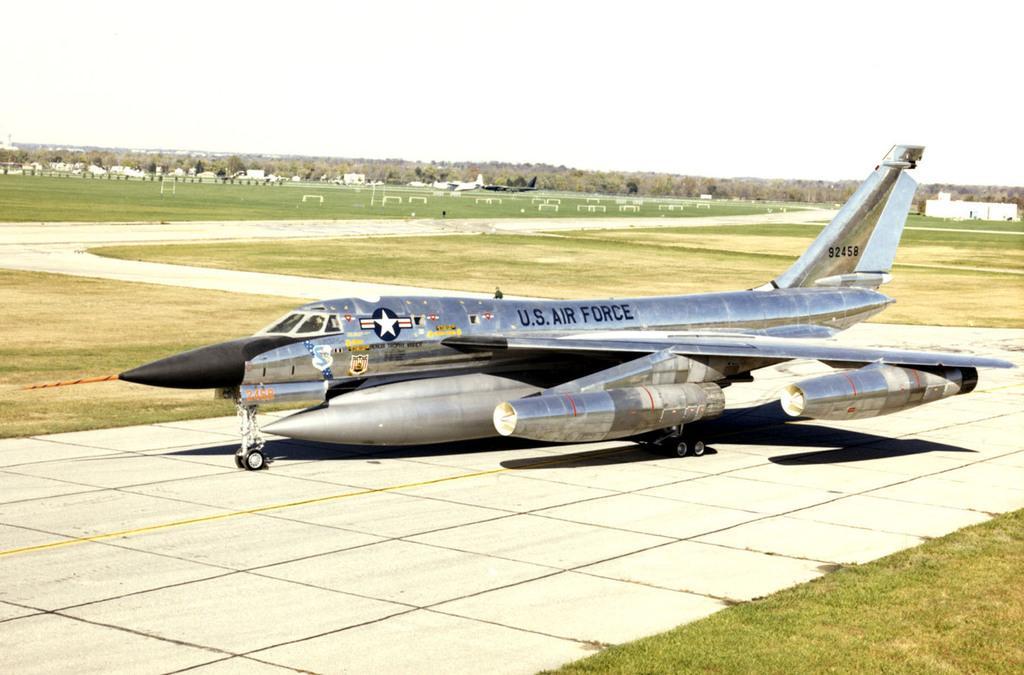Describe this image in one or two sentences. In the foreground of this image, there is an airplane on the runway. On either side to it, there is grassland. In the background, there is grassland, few airplanes, buildings, trees and the sky. 